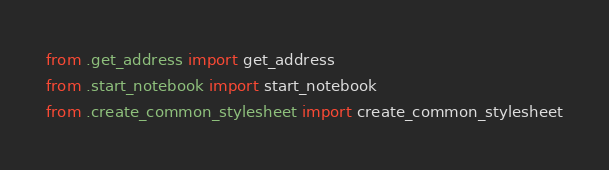<code> <loc_0><loc_0><loc_500><loc_500><_Python_>from .get_address import get_address
from .start_notebook import start_notebook
from .create_common_stylesheet import create_common_stylesheet
</code> 